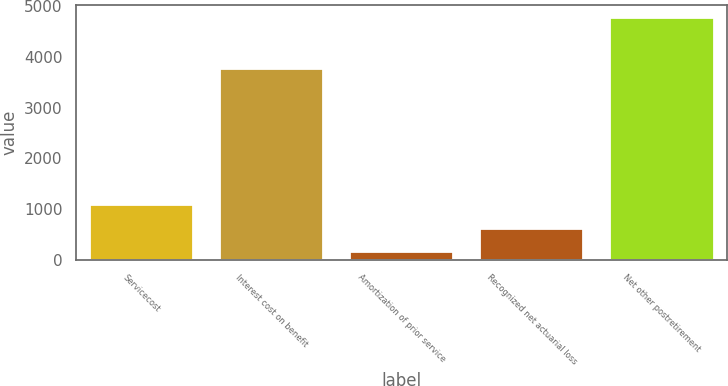<chart> <loc_0><loc_0><loc_500><loc_500><bar_chart><fcel>Servicecost<fcel>Interest cost on benefit<fcel>Amortization of prior service<fcel>Recognized net actuarial loss<fcel>Net other postretirement<nl><fcel>1092.6<fcel>3770<fcel>170<fcel>631.3<fcel>4783<nl></chart> 